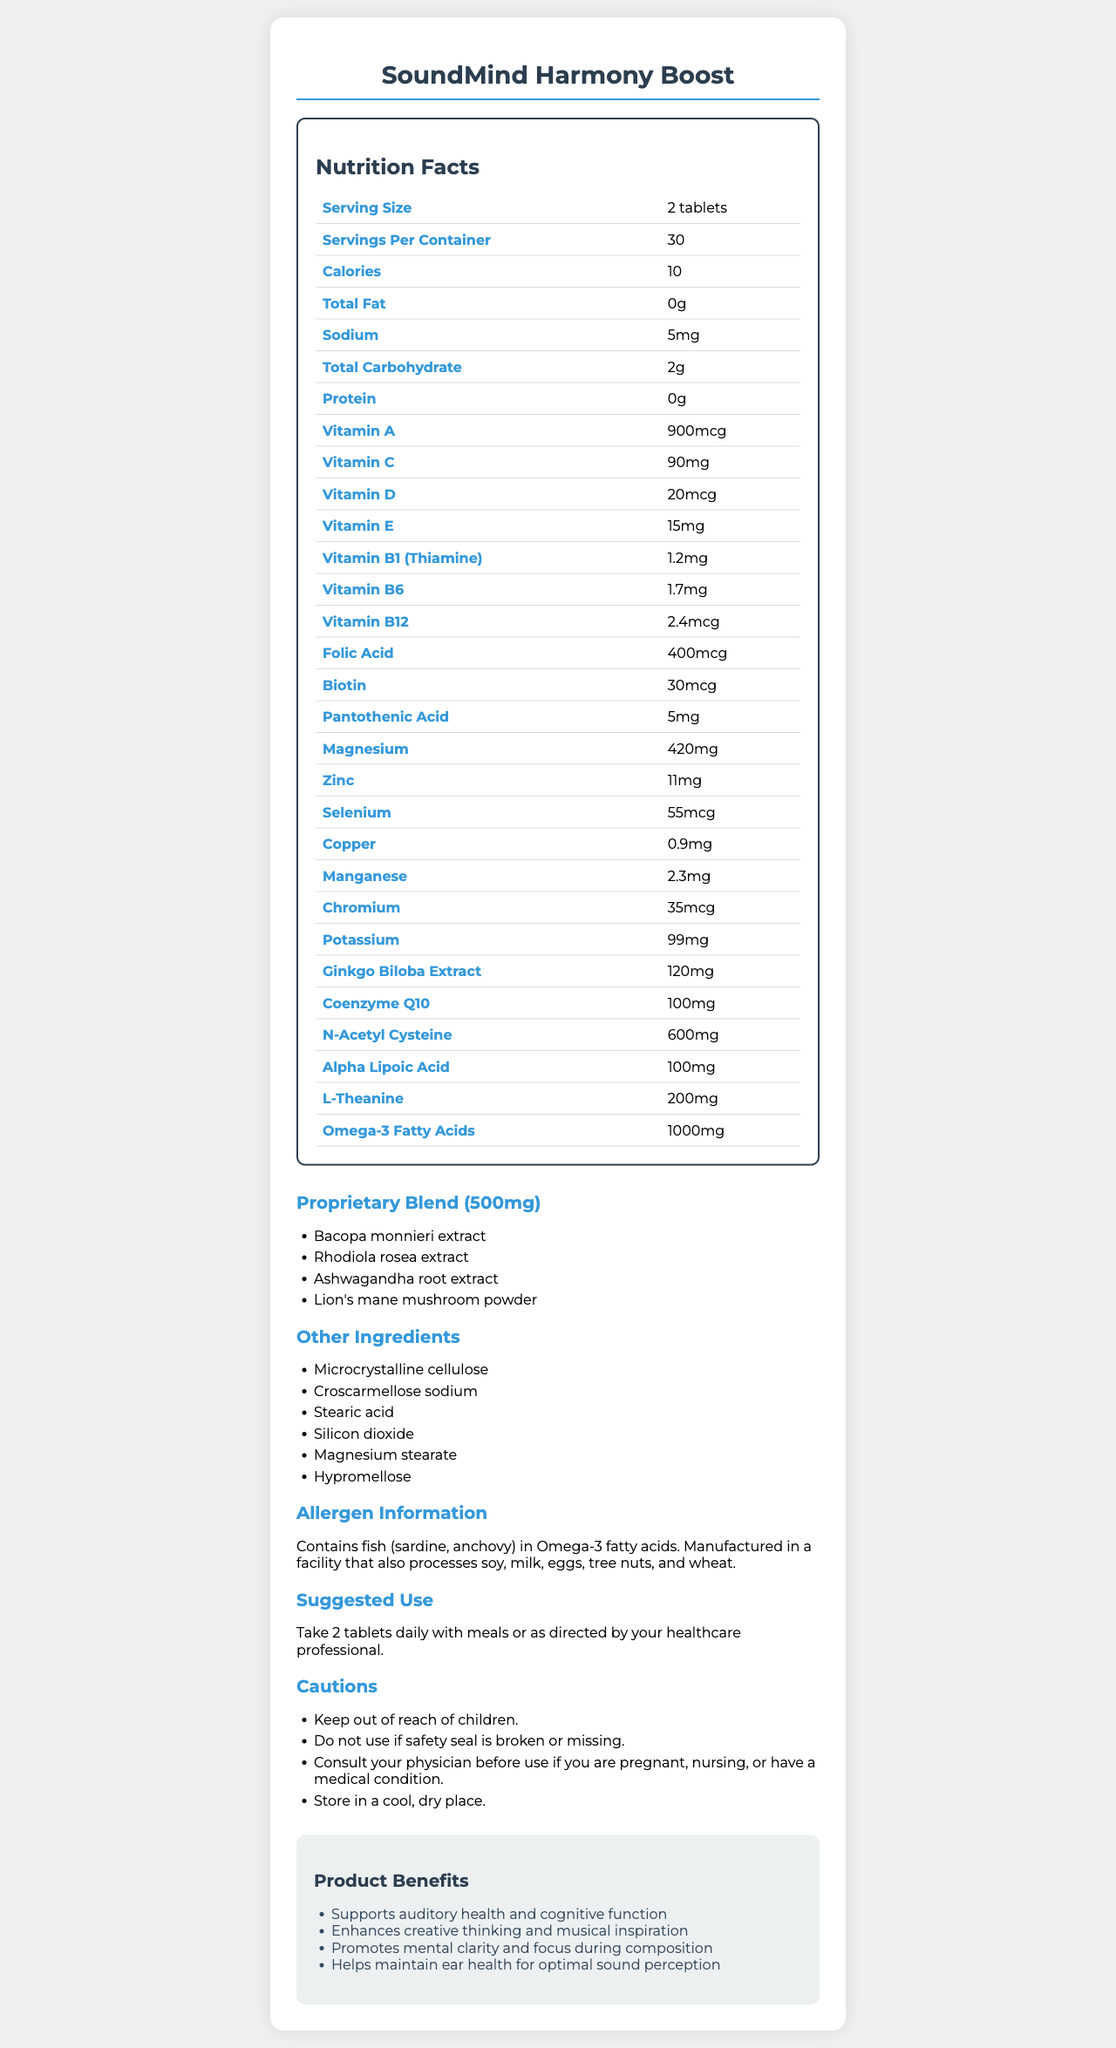what is the serving size of SoundMind Harmony Boost? The document clearly lists the serving size as "2 tablets".
Answer: 2 tablets how many servings are in one container? The document specifies that there are 30 servings per container.
Answer: 30 how much vitamin C does one serving contain? The document states that one serving contains 90mg of vitamin C.
Answer: 90mg what are the main benefits of this supplement? These benefits are listed under the "Product Benefits" section in the document.
Answer: Supports auditory health and cognitive function, Enhances creative thinking and musical inspiration, Promotes mental clarity and focus during composition, Helps maintain ear health for optimal sound perception are there any allergens in this supplement? The allergen information section mentions that the product contains fish (sardine, anchovy) in Omega-3 fatty acids and is manufactured in a facility that processes soy, milk, eggs, tree nuts, and wheat.
Answer: Yes which ingredient has the highest quantity per serving? The document shows that N-Acetyl Cysteine has 600mg per serving, which is the highest among the ingredients listed.
Answer: N-Acetyl Cysteine what is the daily dose of magnesium? The document lists the amount of magnesium per serving as 420mg.
Answer: 420mg does this supplement include any ingredients to support brain function? Ingredients like Ginkgo Biloba Extract, L-Theanine, Bacopa monnieri extract, Rhodiola rosea extract, Ashwagandha root extract, and Lion's mane mushroom powder are known to support brain function.
Answer: Yes which of the following is not an ingredient in the proprietary blend? A. Ashwagandha root extract B. Ginkgo Biloba Extract C. Rhodiola rosea extract D. Bacopa monnieri extract The proprietary blend includes Bacopa monnieri extract, Rhodiola rosea extract, Ashwagandha root extract, and Lion's mane mushroom powder. Ginkgo Biloba Extract is a separate ingredient.
Answer: B. Ginkgo Biloba Extract which vitamin is present in the smallest quantity per serving? A. Vitamin B1 (Thiamine) B. Vitamin B6 C. Biotin D. Vitamin B12 The document indicates that Biotin is present at 30mcg, which is lower than the quantities of Vitamin B1 (1.2mg), Vitamin B6 (1.7mg), and Vitamin B12 (2.4mcg).
Answer: C. Biotin is the supplement safe to use if the safety seal is broken? The caution section explicitly states not to use the product if the safety seal is broken or missing.
Answer: No describe the purpose and key components of SoundMind Harmony Boost based on the document. The explanation summarizes the main sections of the document, covering the purpose, key components, benefits, suggested use, and additional information provided.
Answer: SoundMind Harmony Boost is designed to support auditory health and enhance the cognitive function and creativity of musicians. It contains a variety of vitamins, minerals, and other ingredients like Omega-3 fatty acids, Ginkgo Biloba Extract, Coenzyme Q10, and a proprietary blend of herbal extracts. The product aims to promote mental clarity and focus, creative thinking, and maintain ear health for optimal sound perception. The supplement should be taken as 2 tablets daily with meals. how much stearic acid is in each serving? The document lists stearic acid under "Other Ingredients" but does not specify the amount in each serving.
Answer: Not enough information 